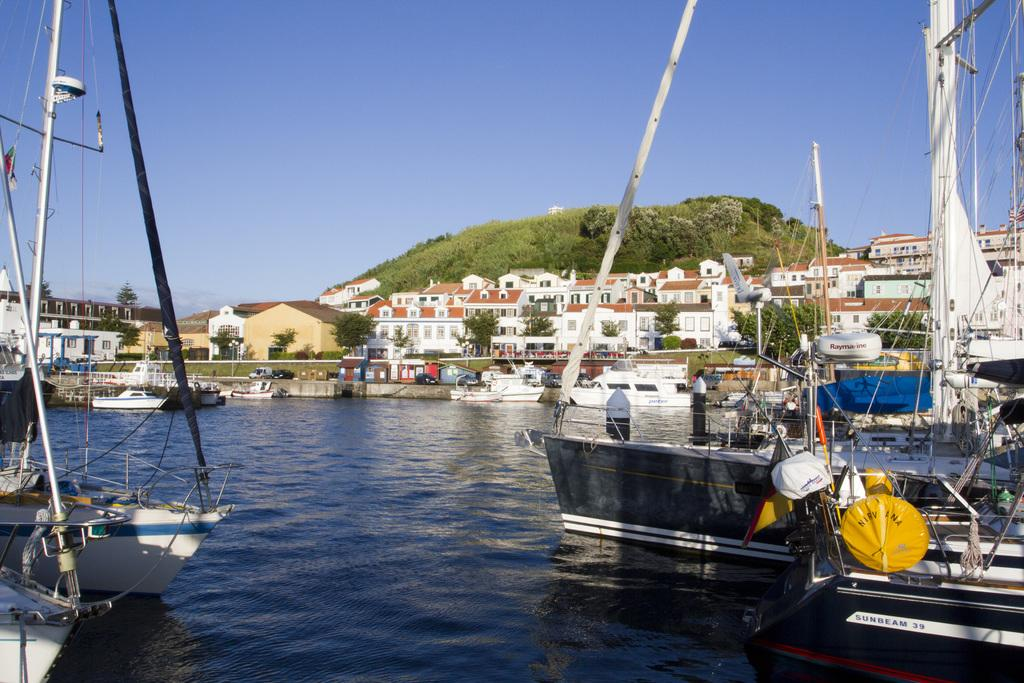What is on the water in the image? There are boats on the water in the image. What can be seen in the background of the image? There are trees, buildings with glass windows, and a mountain in the background. What color is the sky in the image? The sky is blue in the image. Where is the hydrant located in the image? There is no hydrant present in the image. What type of soap is being used to clean the boats in the image? There is no soap or cleaning activity depicted in the image; it simply shows boats on the water. 